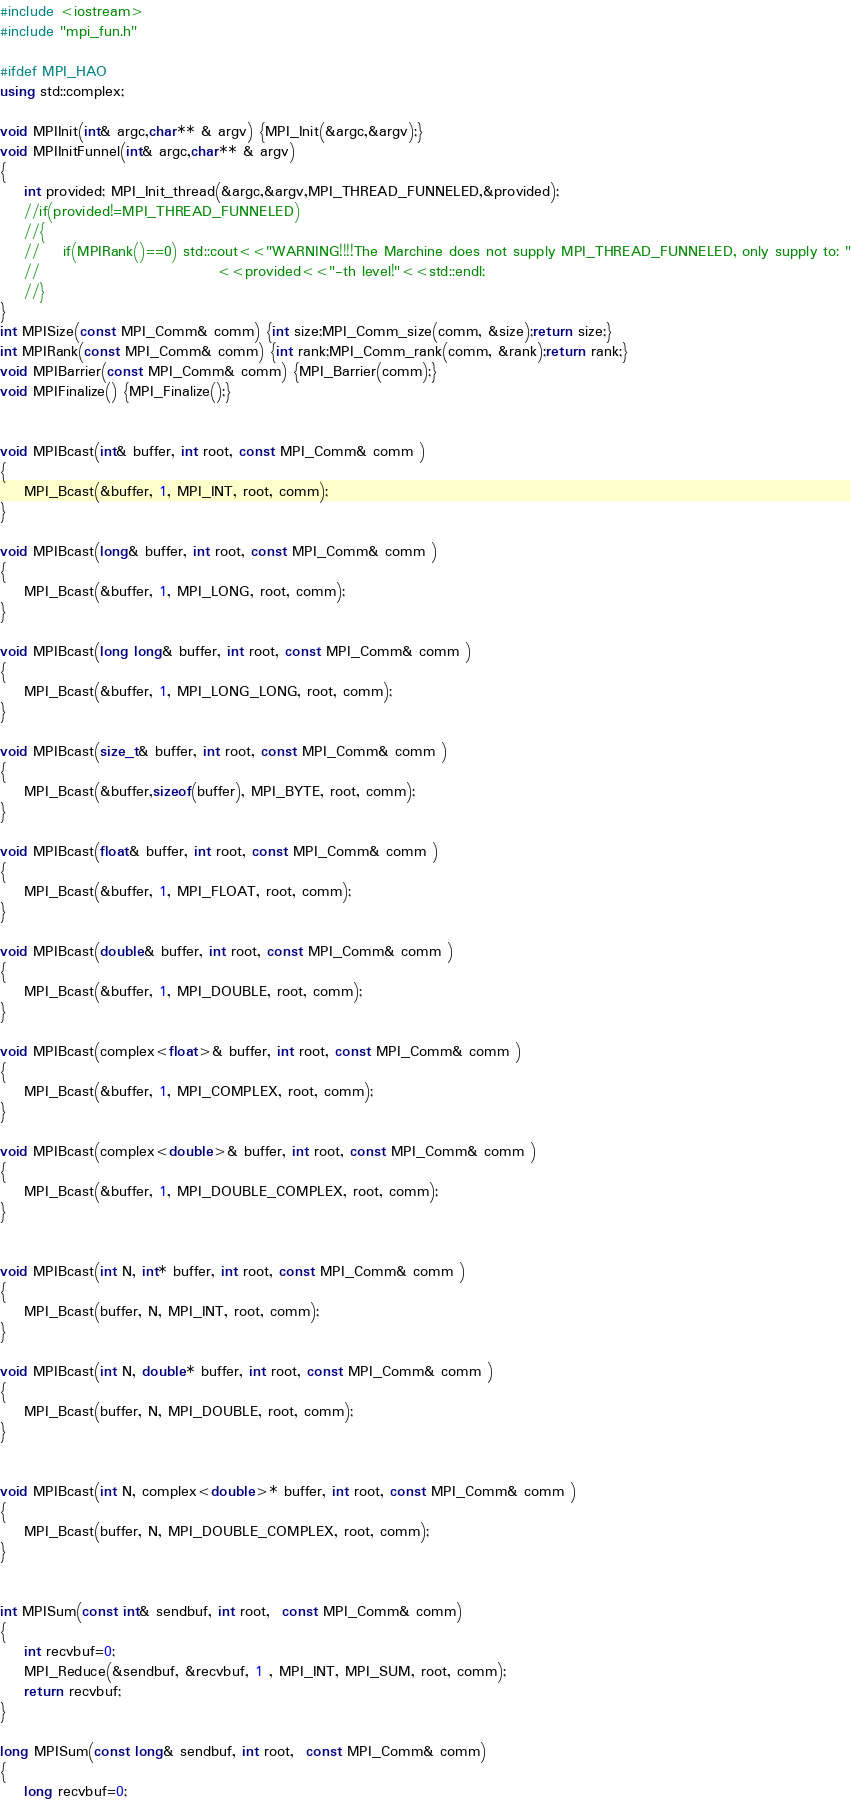Convert code to text. <code><loc_0><loc_0><loc_500><loc_500><_C++_>#include <iostream>
#include "mpi_fun.h"

#ifdef MPI_HAO
using std::complex;

void MPIInit(int& argc,char** & argv) {MPI_Init(&argc,&argv);}
void MPIInitFunnel(int& argc,char** & argv) 
{
    int provided; MPI_Init_thread(&argc,&argv,MPI_THREAD_FUNNELED,&provided);
    //if(provided!=MPI_THREAD_FUNNELED)
    //{
    //    if(MPIRank()==0) std::cout<<"WARNING!!!!The Marchine does not supply MPI_THREAD_FUNNELED, only supply to: "
    //                              <<provided<<"-th level!"<<std::endl;
    //}
}
int MPISize(const MPI_Comm& comm) {int size;MPI_Comm_size(comm, &size);return size;}
int MPIRank(const MPI_Comm& comm) {int rank;MPI_Comm_rank(comm, &rank);return rank;}
void MPIBarrier(const MPI_Comm& comm) {MPI_Barrier(comm);}
void MPIFinalize() {MPI_Finalize();}


void MPIBcast(int& buffer, int root, const MPI_Comm& comm )
{
    MPI_Bcast(&buffer, 1, MPI_INT, root, comm); 
}

void MPIBcast(long& buffer, int root, const MPI_Comm& comm )
{
    MPI_Bcast(&buffer, 1, MPI_LONG, root, comm);
}

void MPIBcast(long long& buffer, int root, const MPI_Comm& comm )
{
    MPI_Bcast(&buffer, 1, MPI_LONG_LONG, root, comm);
}

void MPIBcast(size_t& buffer, int root, const MPI_Comm& comm )
{
    MPI_Bcast(&buffer,sizeof(buffer), MPI_BYTE, root, comm);
}

void MPIBcast(float& buffer, int root, const MPI_Comm& comm )
{
    MPI_Bcast(&buffer, 1, MPI_FLOAT, root, comm);
}

void MPIBcast(double& buffer, int root, const MPI_Comm& comm )
{
    MPI_Bcast(&buffer, 1, MPI_DOUBLE, root, comm);
}

void MPIBcast(complex<float>& buffer, int root, const MPI_Comm& comm )
{
    MPI_Bcast(&buffer, 1, MPI_COMPLEX, root, comm);
}

void MPIBcast(complex<double>& buffer, int root, const MPI_Comm& comm )
{
    MPI_Bcast(&buffer, 1, MPI_DOUBLE_COMPLEX, root, comm);
}


void MPIBcast(int N, int* buffer, int root, const MPI_Comm& comm )
{
    MPI_Bcast(buffer, N, MPI_INT, root, comm);
}

void MPIBcast(int N, double* buffer, int root, const MPI_Comm& comm )
{
    MPI_Bcast(buffer, N, MPI_DOUBLE, root, comm);
}


void MPIBcast(int N, complex<double>* buffer, int root, const MPI_Comm& comm )
{
    MPI_Bcast(buffer, N, MPI_DOUBLE_COMPLEX, root, comm);
}


int MPISum(const int& sendbuf, int root,  const MPI_Comm& comm)
{
    int recvbuf=0;
    MPI_Reduce(&sendbuf, &recvbuf, 1 , MPI_INT, MPI_SUM, root, comm);
    return recvbuf;
}

long MPISum(const long& sendbuf, int root,  const MPI_Comm& comm)
{
    long recvbuf=0;</code> 